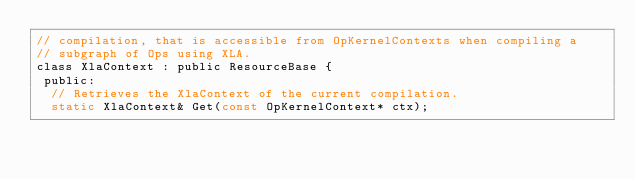Convert code to text. <code><loc_0><loc_0><loc_500><loc_500><_C_>// compilation, that is accessible from OpKernelContexts when compiling a
// subgraph of Ops using XLA.
class XlaContext : public ResourceBase {
 public:
  // Retrieves the XlaContext of the current compilation.
  static XlaContext& Get(const OpKernelContext* ctx);</code> 